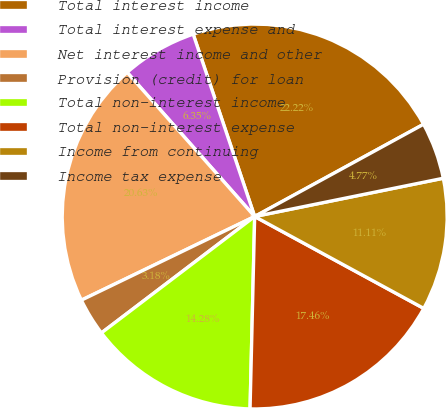<chart> <loc_0><loc_0><loc_500><loc_500><pie_chart><fcel>Total interest income<fcel>Total interest expense and<fcel>Net interest income and other<fcel>Provision (credit) for loan<fcel>Total non-interest income<fcel>Total non-interest expense<fcel>Income from continuing<fcel>Income tax expense<nl><fcel>22.22%<fcel>6.35%<fcel>20.63%<fcel>3.18%<fcel>14.28%<fcel>17.46%<fcel>11.11%<fcel>4.77%<nl></chart> 